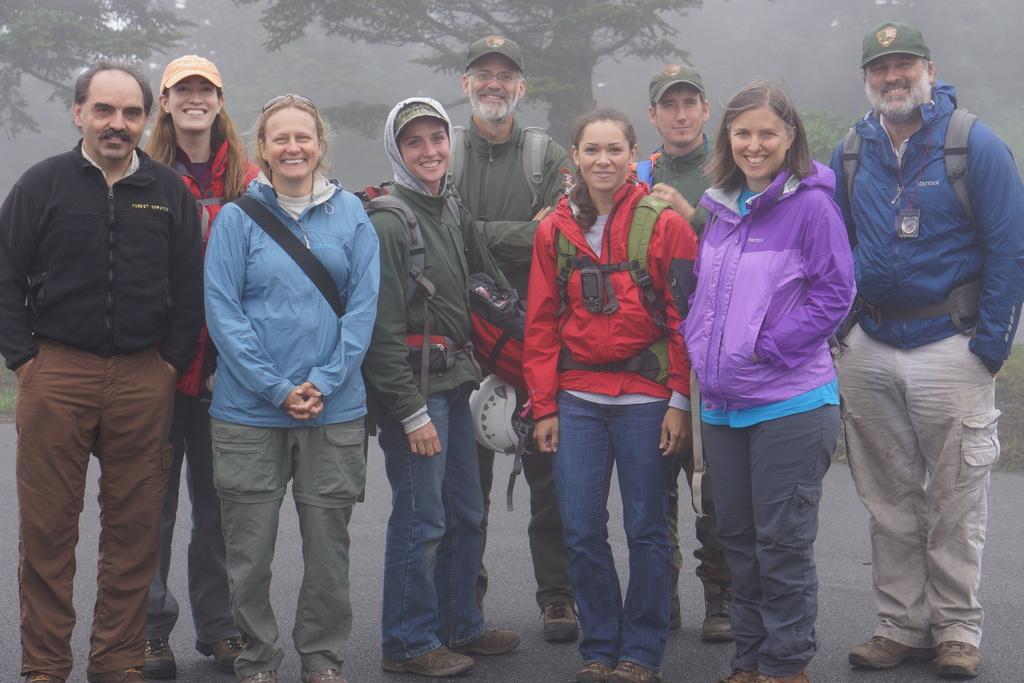Can you describe this image briefly? In the image there are few people standing. In those few people there are five persons with caps on their heads. And there are few people wearing bags. Behind those people there are trees. 